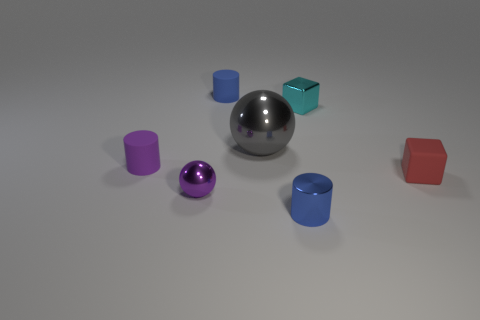Subtract all tiny matte cylinders. How many cylinders are left? 1 Subtract 1 cylinders. How many cylinders are left? 2 Add 3 rubber things. How many objects exist? 10 Subtract all yellow spheres. How many blue cylinders are left? 2 Subtract all cylinders. How many objects are left? 4 Add 1 blue matte things. How many blue matte things are left? 2 Add 6 large gray objects. How many large gray objects exist? 7 Subtract 0 yellow spheres. How many objects are left? 7 Subtract all red blocks. Subtract all green cylinders. How many blocks are left? 1 Subtract all small cyan cubes. Subtract all gray shiny balls. How many objects are left? 5 